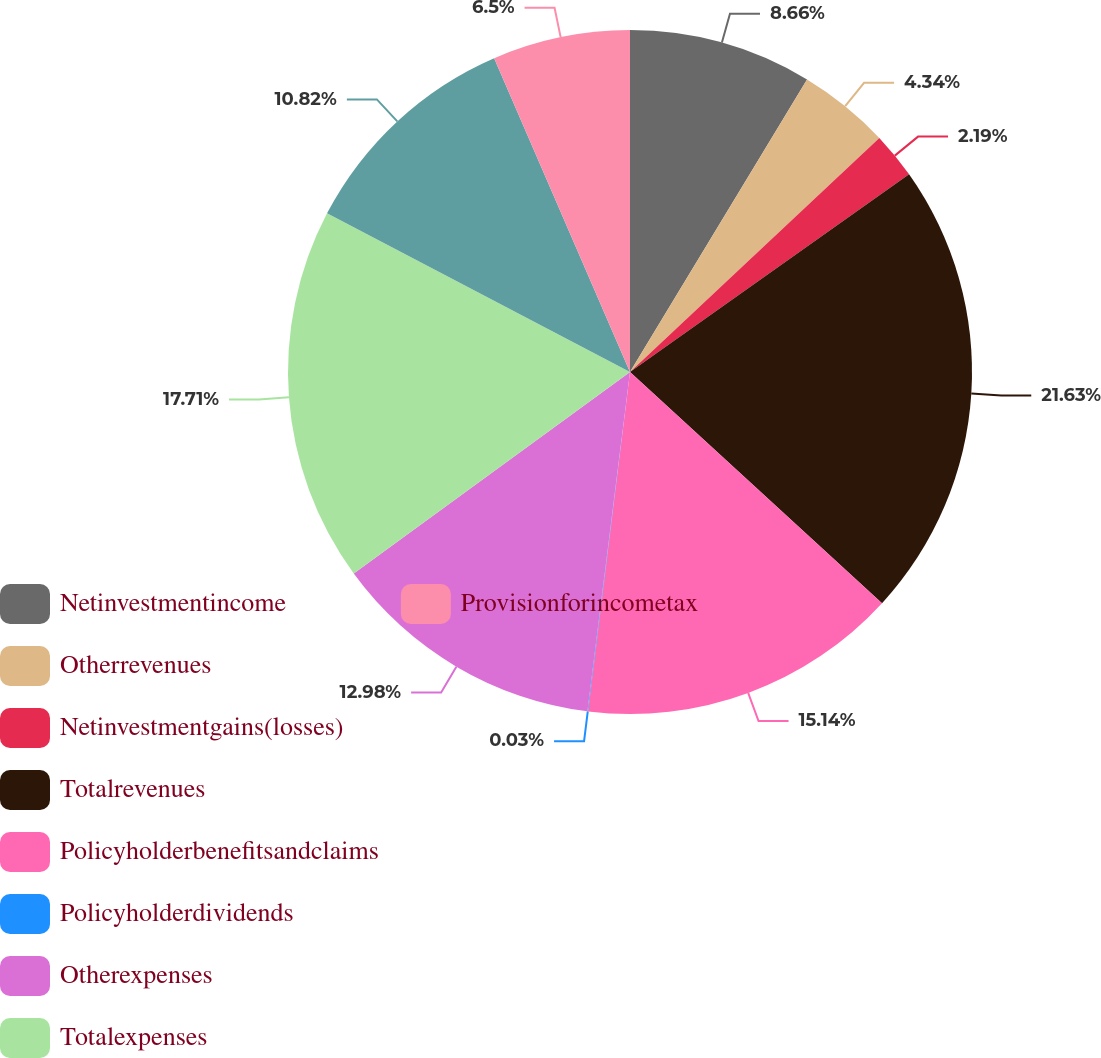Convert chart to OTSL. <chart><loc_0><loc_0><loc_500><loc_500><pie_chart><fcel>Netinvestmentincome<fcel>Otherrevenues<fcel>Netinvestmentgains(losses)<fcel>Totalrevenues<fcel>Policyholderbenefitsandclaims<fcel>Policyholderdividends<fcel>Otherexpenses<fcel>Totalexpenses<fcel>Unnamed: 8<fcel>Provisionforincometax<nl><fcel>8.66%<fcel>4.34%<fcel>2.19%<fcel>21.62%<fcel>15.14%<fcel>0.03%<fcel>12.98%<fcel>17.71%<fcel>10.82%<fcel>6.5%<nl></chart> 